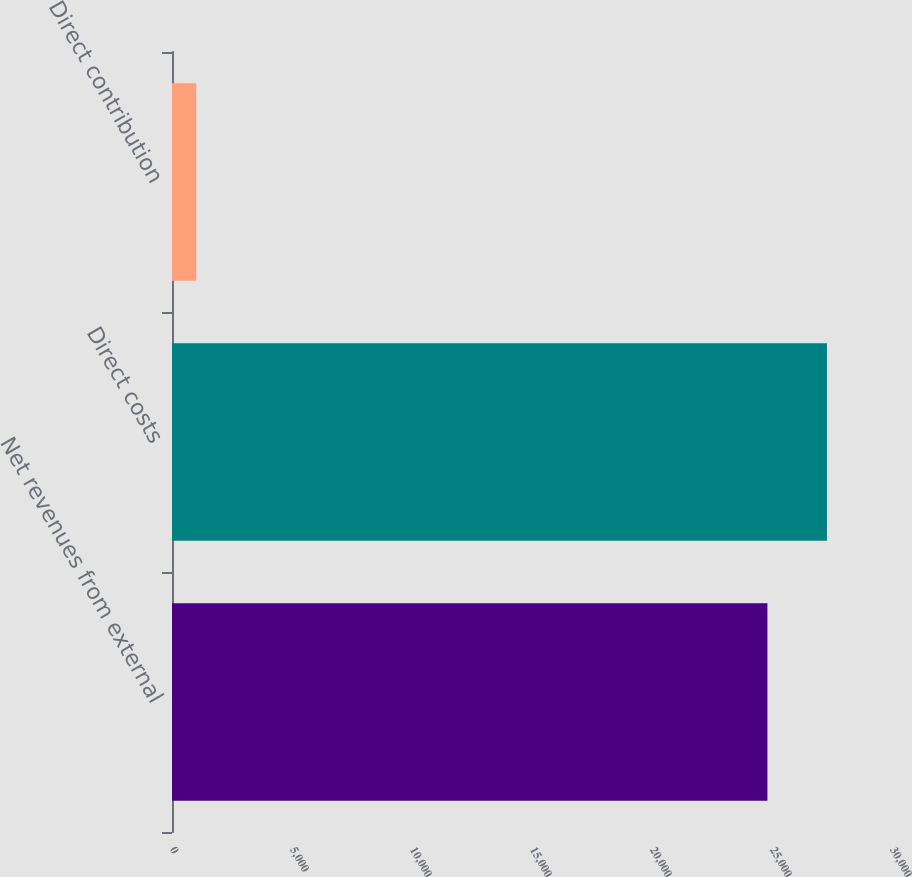<chart> <loc_0><loc_0><loc_500><loc_500><bar_chart><fcel>Net revenues from external<fcel>Direct costs<fcel>Direct contribution<nl><fcel>24809<fcel>27289.9<fcel>1012<nl></chart> 